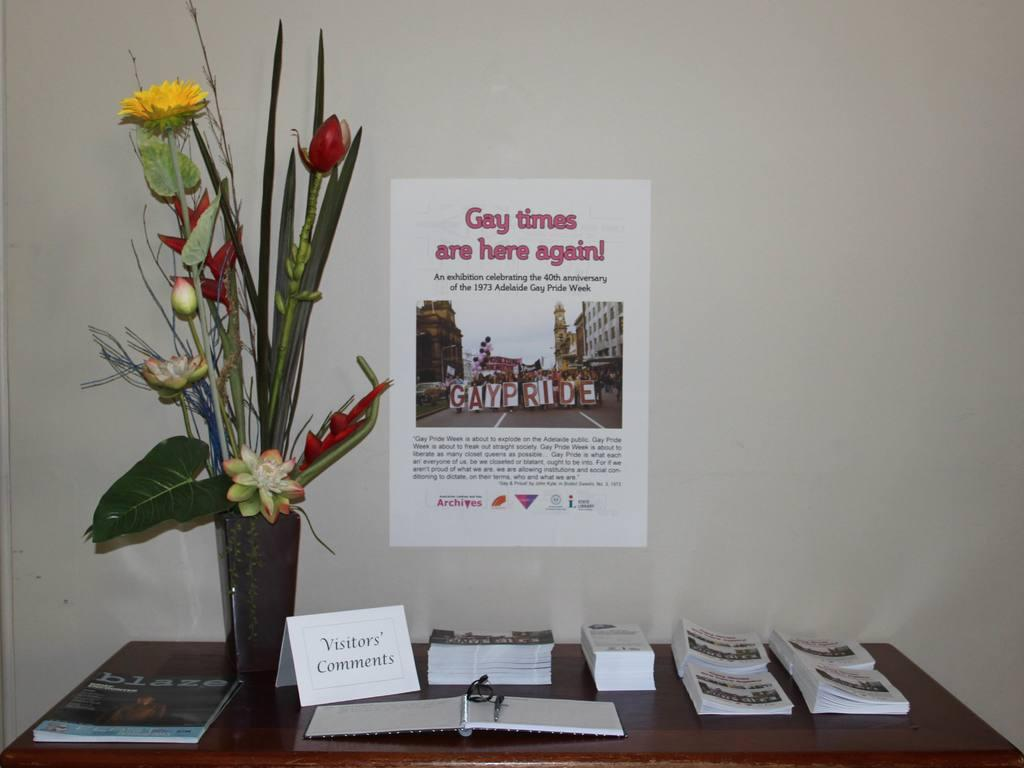What objects can be seen on the table in the image? There are books and a card with visitors' comments on the table. What else is present on the table? There is a flower vase on the table. What can be seen on the wall in the image? There is a poster on the wall. What type of trees can be seen on the stage in the image? There is no stage or trees present in the image. Is there a flame visible in the image? There is no flame visible in the image. 